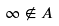Convert formula to latex. <formula><loc_0><loc_0><loc_500><loc_500>\infty \notin A</formula> 